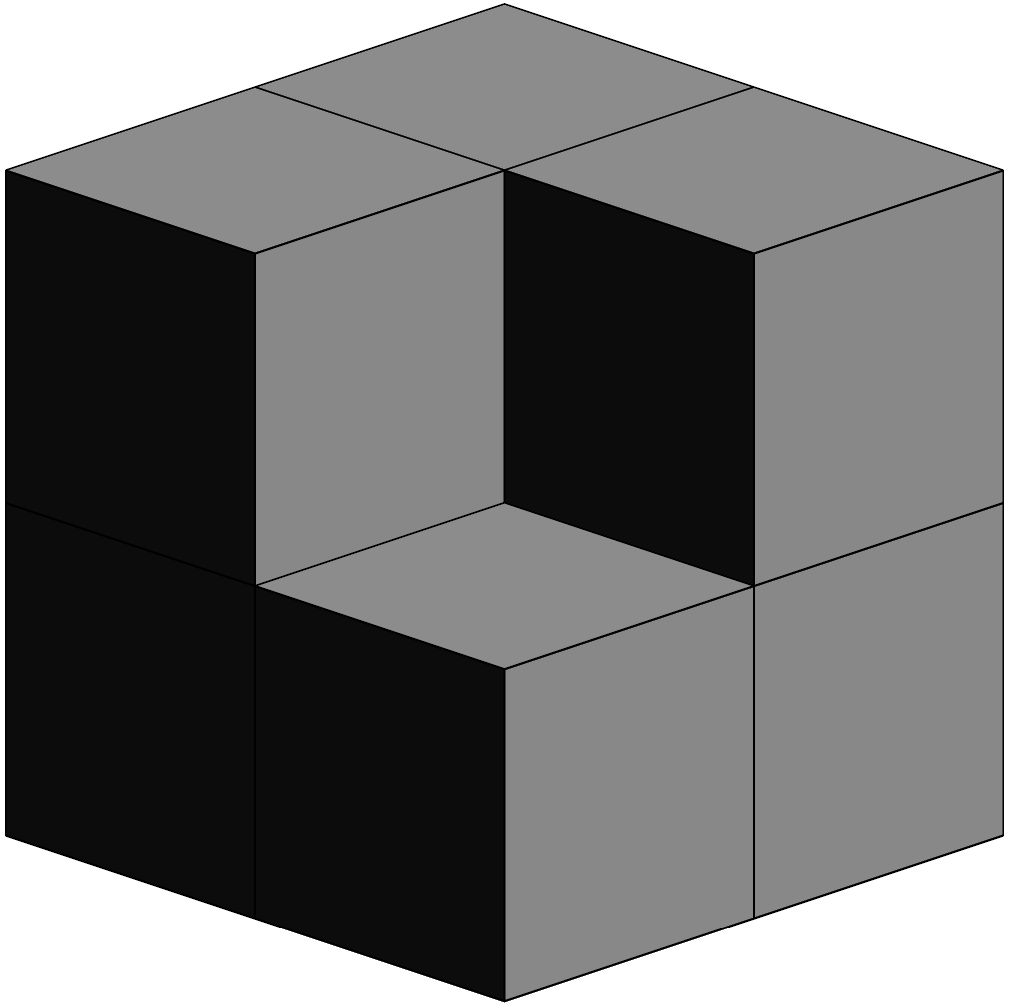As part of a study on the integration of spatial reasoning in STEM education, you're presented with a 3D structure composed of unit cubes. The structure is shown from an isometric view. Given that the base of the structure is a 2x2 square, and no cube is floating in mid-air, how many cubes are there in total? To solve this problem, we need to analyze the 3D structure systematically:

1. First, observe the base layer:
   - The base is a 2x2 square, so it contains 4 cubes.

2. Next, examine the second layer:
   - We can see 3 cubes on top of the base layer.
   - The cube in the back-right corner of the base is not visible, but we can deduce its absence because the top-right edge of the structure is clearly visible.

3. Finally, look at the top layer:
   - There is only one cube visible on the top, which is in the back-left corner.

4. Sum up the cubes:
   - Base layer: 4 cubes
   - Second layer: 3 cubes
   - Top layer: 1 cube
   - Total: $4 + 3 + 1 = 8$ cubes

This exercise demonstrates how spatial reasoning skills can be integrated into STEM education, encouraging students to visualize and analyze 3D structures from 2D representations. It combines elements of geometry, logical thinking, and visual perception, which are crucial in many STEM fields.
Answer: 8 cubes 